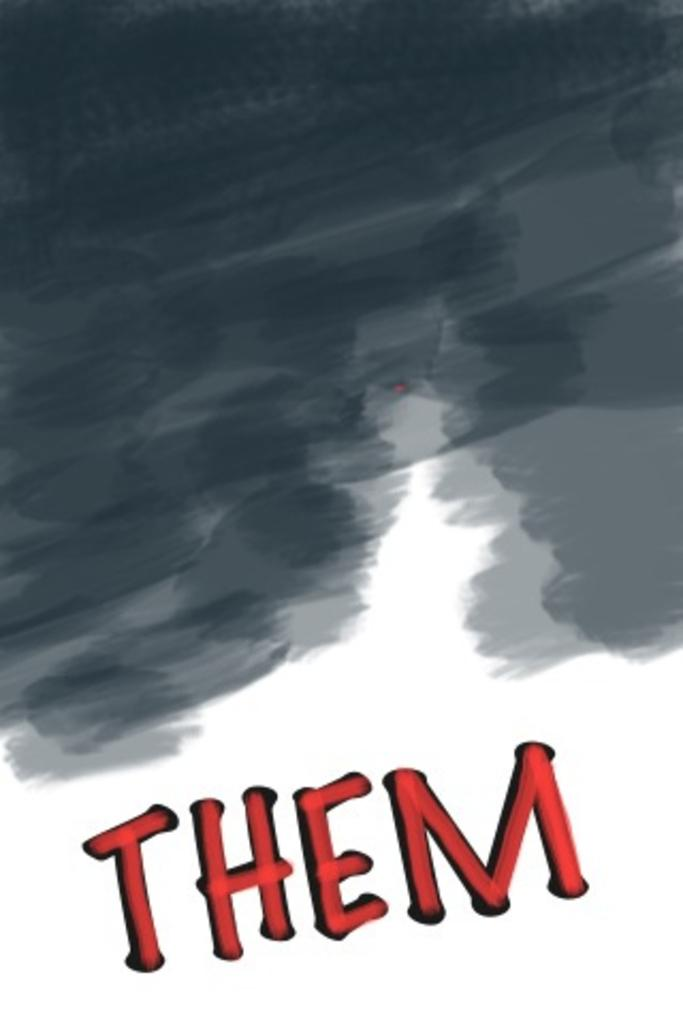What can be found at the bottom of the image? There is text at the bottom of the image. What color shade is present at the top of the image? There is a black color shade at the top of the image. Can you tell me how many people are running in the image? There is no indication of people running in the image. What type of fire is visible in the image? There is no fire present in the image. 